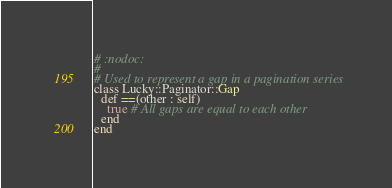<code> <loc_0><loc_0><loc_500><loc_500><_Crystal_># :nodoc:
#
# Used to represent a gap in a pagination series
class Lucky::Paginator::Gap
  def ==(other : self)
    true # All gaps are equal to each other
  end
end
</code> 